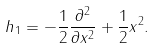<formula> <loc_0><loc_0><loc_500><loc_500>h _ { 1 } = - \frac { 1 } { 2 } \frac { \partial ^ { 2 } } { \partial x ^ { 2 } } + \frac { 1 } { 2 } x ^ { 2 } .</formula> 